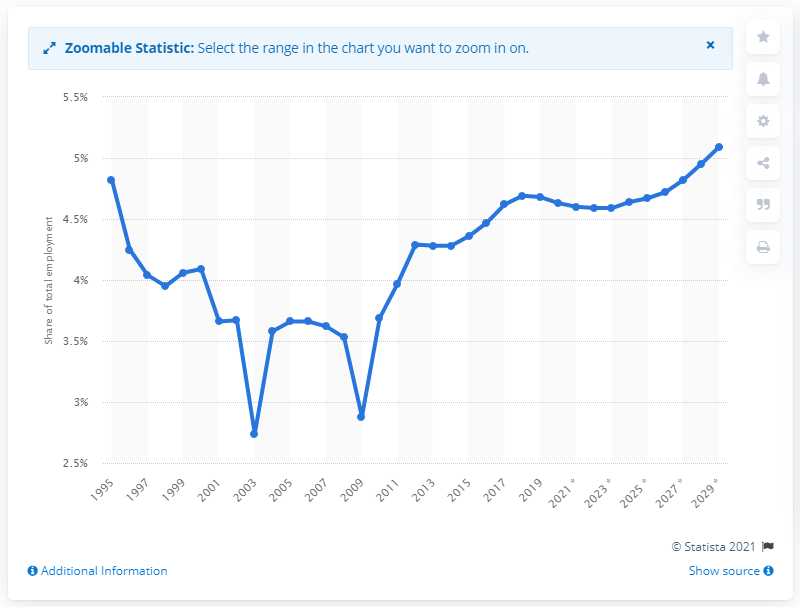Identify some key points in this picture. In 2019, tourism made up approximately 4.72% of Singapore's total employment. 